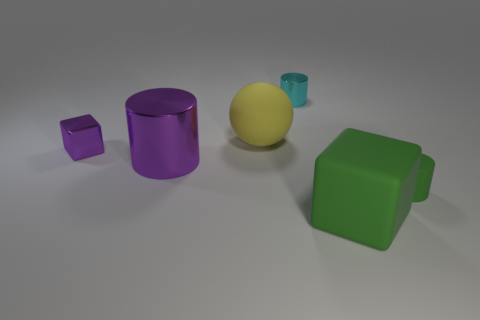Add 1 tiny rubber cylinders. How many objects exist? 7 Subtract all large purple shiny cylinders. How many cylinders are left? 2 Subtract all small purple metal cubes. Subtract all small metallic cylinders. How many objects are left? 4 Add 5 yellow spheres. How many yellow spheres are left? 6 Add 1 large brown shiny spheres. How many large brown shiny spheres exist? 1 Subtract all purple cylinders. How many cylinders are left? 2 Subtract 0 cyan balls. How many objects are left? 6 Subtract all spheres. How many objects are left? 5 Subtract 1 blocks. How many blocks are left? 1 Subtract all yellow cylinders. Subtract all red blocks. How many cylinders are left? 3 